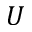<formula> <loc_0><loc_0><loc_500><loc_500>U</formula> 